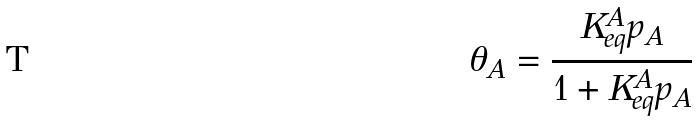Convert formula to latex. <formula><loc_0><loc_0><loc_500><loc_500>\theta _ { A } = \frac { K _ { e q } ^ { A } p _ { A } } { 1 + K _ { e q } ^ { A } p _ { A } }</formula> 